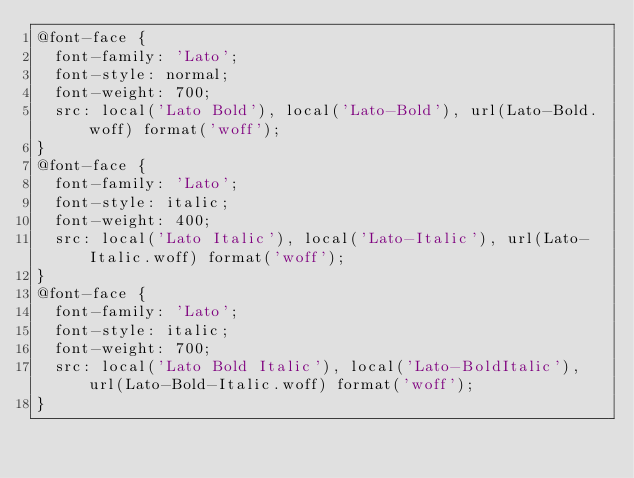Convert code to text. <code><loc_0><loc_0><loc_500><loc_500><_CSS_>@font-face {
  font-family: 'Lato';
  font-style: normal;
  font-weight: 700;
  src: local('Lato Bold'), local('Lato-Bold'), url(Lato-Bold.woff) format('woff');
}
@font-face {
  font-family: 'Lato';
  font-style: italic;
  font-weight: 400;
  src: local('Lato Italic'), local('Lato-Italic'), url(Lato-Italic.woff) format('woff');
}
@font-face {
  font-family: 'Lato';
  font-style: italic;
  font-weight: 700;
  src: local('Lato Bold Italic'), local('Lato-BoldItalic'), url(Lato-Bold-Italic.woff) format('woff');
}</code> 